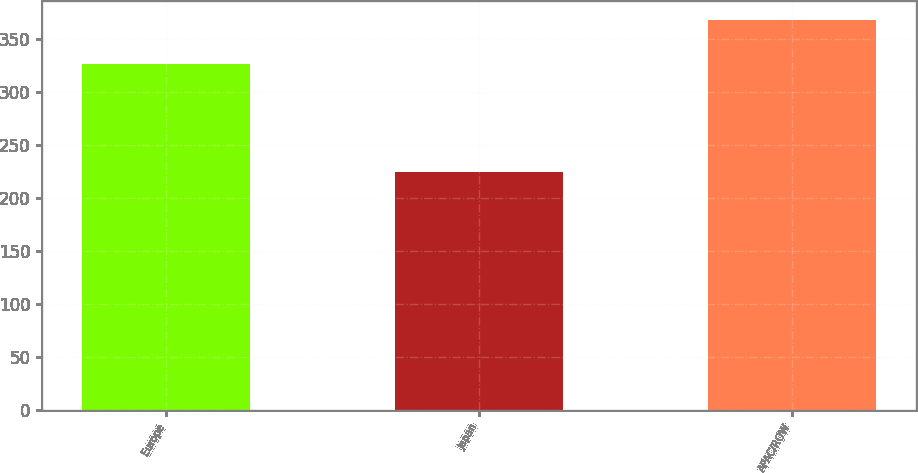Convert chart to OTSL. <chart><loc_0><loc_0><loc_500><loc_500><bar_chart><fcel>Europe<fcel>Japan<fcel>APAC/ROW<nl><fcel>326.1<fcel>224.1<fcel>367.9<nl></chart> 